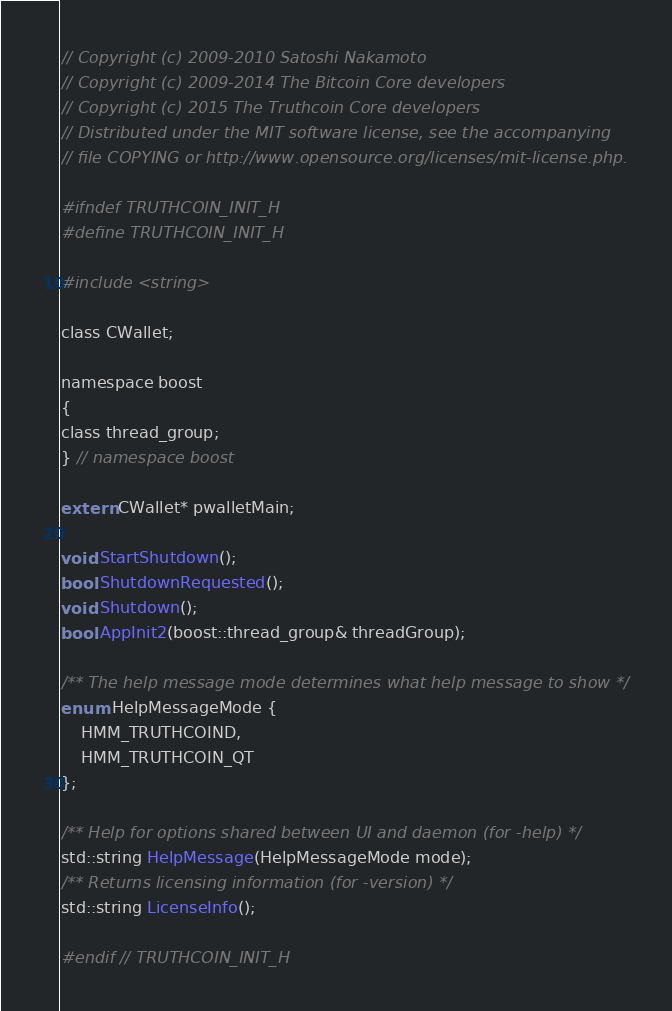<code> <loc_0><loc_0><loc_500><loc_500><_C_>// Copyright (c) 2009-2010 Satoshi Nakamoto
// Copyright (c) 2009-2014 The Bitcoin Core developers
// Copyright (c) 2015 The Truthcoin Core developers
// Distributed under the MIT software license, see the accompanying
// file COPYING or http://www.opensource.org/licenses/mit-license.php.

#ifndef TRUTHCOIN_INIT_H
#define TRUTHCOIN_INIT_H

#include <string>

class CWallet;

namespace boost
{
class thread_group;
} // namespace boost

extern CWallet* pwalletMain;

void StartShutdown();
bool ShutdownRequested();
void Shutdown();
bool AppInit2(boost::thread_group& threadGroup);

/** The help message mode determines what help message to show */
enum HelpMessageMode {
    HMM_TRUTHCOIND,
    HMM_TRUTHCOIN_QT
};

/** Help for options shared between UI and daemon (for -help) */
std::string HelpMessage(HelpMessageMode mode);
/** Returns licensing information (for -version) */
std::string LicenseInfo();

#endif // TRUTHCOIN_INIT_H
</code> 